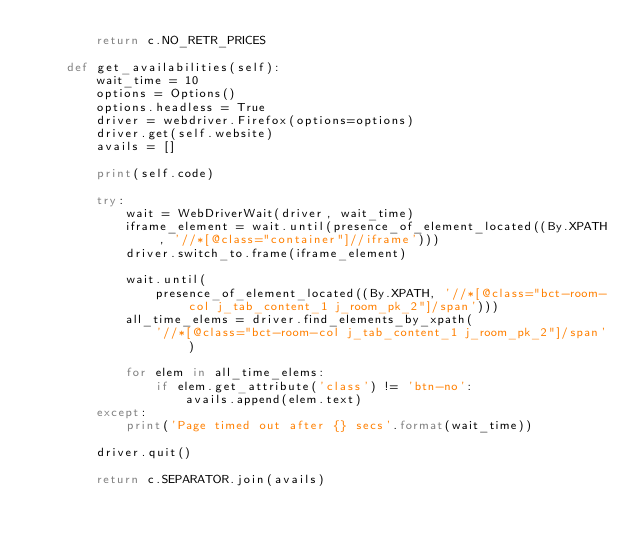Convert code to text. <code><loc_0><loc_0><loc_500><loc_500><_Python_>        return c.NO_RETR_PRICES

    def get_availabilities(self):
        wait_time = 10
        options = Options()
        options.headless = True
        driver = webdriver.Firefox(options=options)
        driver.get(self.website)
        avails = []

        print(self.code)

        try:
            wait = WebDriverWait(driver, wait_time)
            iframe_element = wait.until(presence_of_element_located((By.XPATH, '//*[@class="container"]//iframe')))
            driver.switch_to.frame(iframe_element)

            wait.until(
                presence_of_element_located((By.XPATH, '//*[@class="bct-room-col j_tab_content_1 j_room_pk_2"]/span')))
            all_time_elems = driver.find_elements_by_xpath(
                '//*[@class="bct-room-col j_tab_content_1 j_room_pk_2"]/span')

            for elem in all_time_elems:
                if elem.get_attribute('class') != 'btn-no':
                    avails.append(elem.text)
        except:
            print('Page timed out after {} secs'.format(wait_time))

        driver.quit()

        return c.SEPARATOR.join(avails)
</code> 